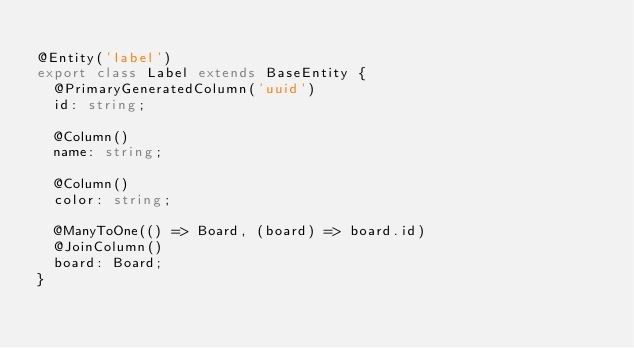<code> <loc_0><loc_0><loc_500><loc_500><_TypeScript_>
@Entity('label')
export class Label extends BaseEntity {
  @PrimaryGeneratedColumn('uuid')
  id: string;

  @Column()
  name: string;

  @Column()
  color: string;

  @ManyToOne(() => Board, (board) => board.id)
  @JoinColumn()
  board: Board;
}
</code> 